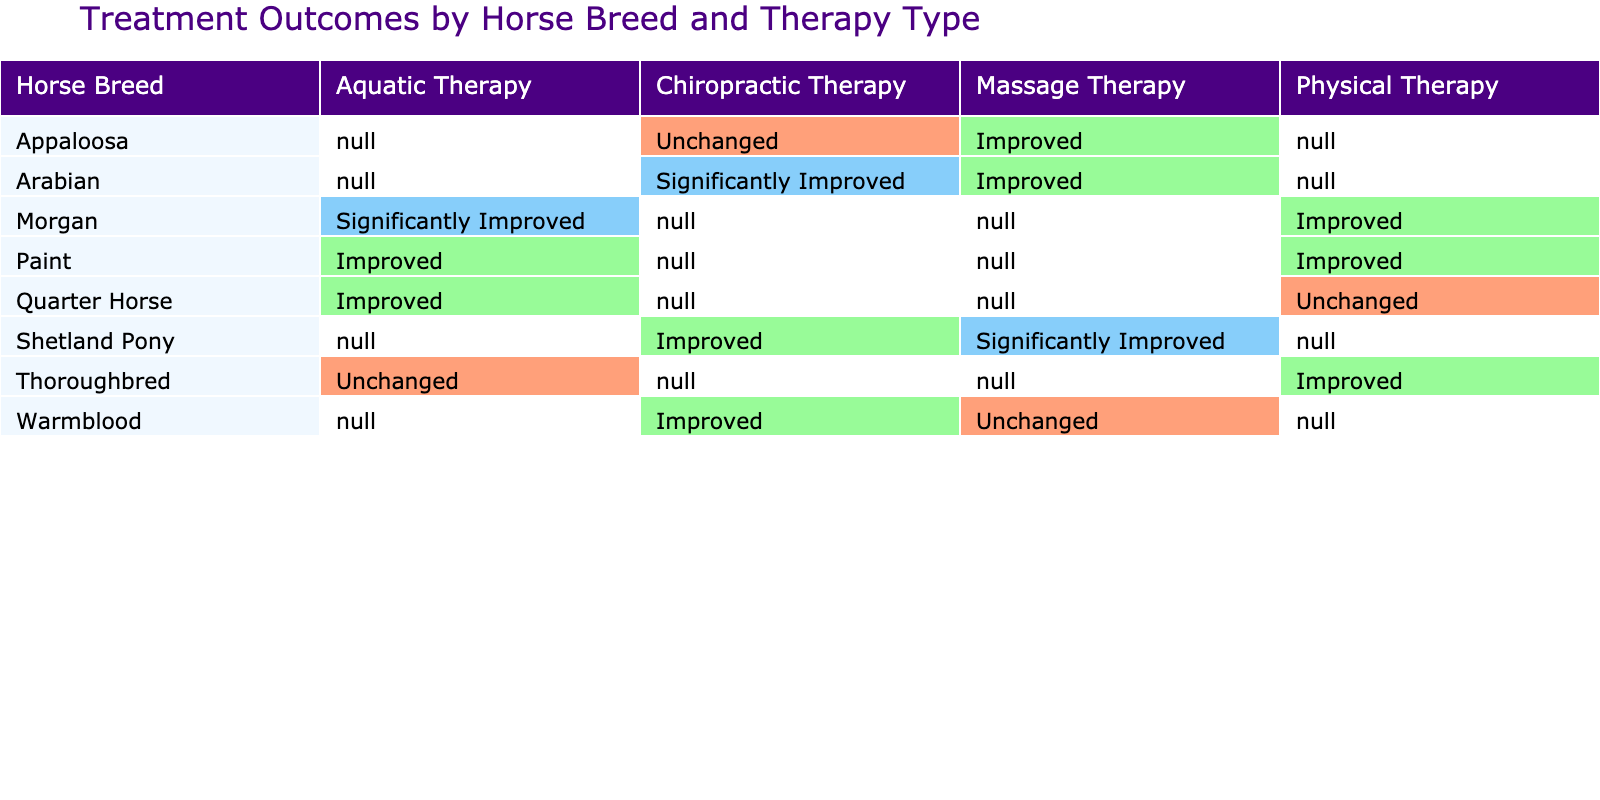What is the treatment outcome for Thoroughbreds receiving Aquatic Therapy? The table shows that for Thoroughbreds receiving Aquatic Therapy, the treatment outcome is "Unchanged". This is a straightforward retrieval question directly answered by looking at the relevant row.
Answer: Unchanged Which horse breed had the highest number of "Significantly Improved" outcomes? By inspecting the column for "Significantly Improved", the only breeds that show this outcome are Arabian, Morgan, and Shetland Pony. However, upon counting, Shetland Pony had 1 count, while Arabian had 1, and Morgan also had 1. Therefore, there is a tie.
Answer: None; it's tied (Arabian, Morgan, Shetland Pony) How many different therapy types resulted in an "Improved" outcome for Quarter Horses? The relevant rows show Quarter Horses with two therapy types: Physical Therapy (Unchanged) and Aquatic Therapy (Improved). The only therapy type showing "Improved" is Aquatic Therapy. So, there is only 1 type resulting in "Improved".
Answer: 1 Does any therapy type lead to "Unchanged" outcomes for all horse breeds? Checking the table, we find that various breeds have outcomes showing "Unchanged", but not for all breeds; both the Physical and Massage Therapy show "Unchanged" in multiple breeds. Therefore, this statement is false.
Answer: No What is the total number of "Improved" outcomes across all therapy types for Morgan horses? We check the table for Morgan horses and find that they have "Improved" outcomes from Physical Therapy and Aquatic Therapy. Therefore, the total number of "Improved" outcomes for Morgans is 2.
Answer: 2 In terms of therapy type, which has the greatest variety of outcomes and how many outcomes are present in that type? Examining the various therapy types, it can be seen that Aquatic Therapy shows outcomes of "Improved" and "Unchanged", while the rest have less variety. In total, Aquatic Therapy presents two distinct outcomes.
Answer: Aquatic Therapy; 2 outcomes Which horse breed had both "Improved" and "Unchanged" outcomes across different therapies? Looking through the table, I find the breeds that show both "Improved" and "Unchanged" outcomes; notably, Quarter Horse with Aquatic Therapy (Improved) and Physical Therapy (Unchanged) fits this description.
Answer: Quarter Horse 